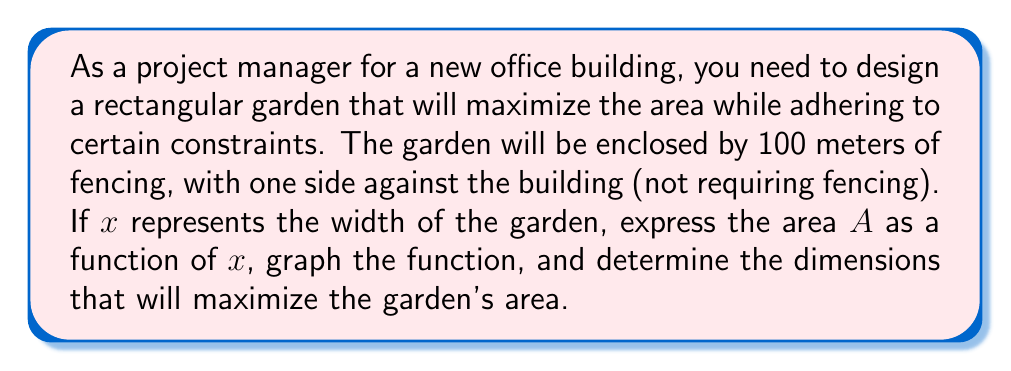Solve this math problem. Let's approach this step-by-step:

1) First, let's define our variables:
   $x$ = width of the garden
   $y$ = length of the garden
   $A$ = area of the garden

2) We know that the perimeter (excluding the side against the building) is 100 meters:
   $$ x + 2y = 100 $$

3) We can solve this for $y$:
   $$ y = 50 - \frac{x}{2} $$

4) The area of a rectangle is length times width, so:
   $$ A = xy = x(50 - \frac{x}{2}) = 50x - \frac{x^2}{2} $$

5) This is our quadratic function. Let's simplify it:
   $$ A(x) = -\frac{1}{2}x^2 + 50x $$

6) To graph this function, we need to identify key points:
   - y-intercept: When $x = 0$, $A = 0$
   - x-intercepts: When $A = 0$, $x = 0$ or $x = 100$
   - Vertex: The vertex form of a quadratic is $-\frac{1}{2}(x-h)^2 + k$
     where $(h,k)$ is the vertex. Comparing to our equation:
     $$ -\frac{1}{2}x^2 + 50x = -\frac{1}{2}(x^2 - 100x) = -\frac{1}{2}(x-50)^2 + 1250 $$
     So the vertex is at $(50, 1250)$

7) Here's a graph of the function:

[asy]
import graph;
size(200,200);
real f(real x) {return -0.5*x^2 + 50*x;}
draw(graph(f,0,100));
xaxis("x",0,100,Arrow);
yaxis("A",0,1300,Arrow);
label("(50, 1250)",( 50,1250),NE);
label("(0, 0)",(0,0),SW);
label("(100, 0)",(100,0),SE);
dot((50,1250));
dot((0,0));
dot((100,0));
[/asy]

8) The maximum point of the parabola is at its vertex, $(50, 1250)$. This means the maximum area is achieved when the width is 50 meters.

9) To find the length at this point, we substitute $x = 50$ into our equation for $y$:
   $$ y = 50 - \frac{50}{2} = 25 $$

Therefore, the dimensions that maximize the garden's area are 50 meters wide by 25 meters long, creating a maximum area of 1250 square meters.
Answer: 50 meters wide, 25 meters long 